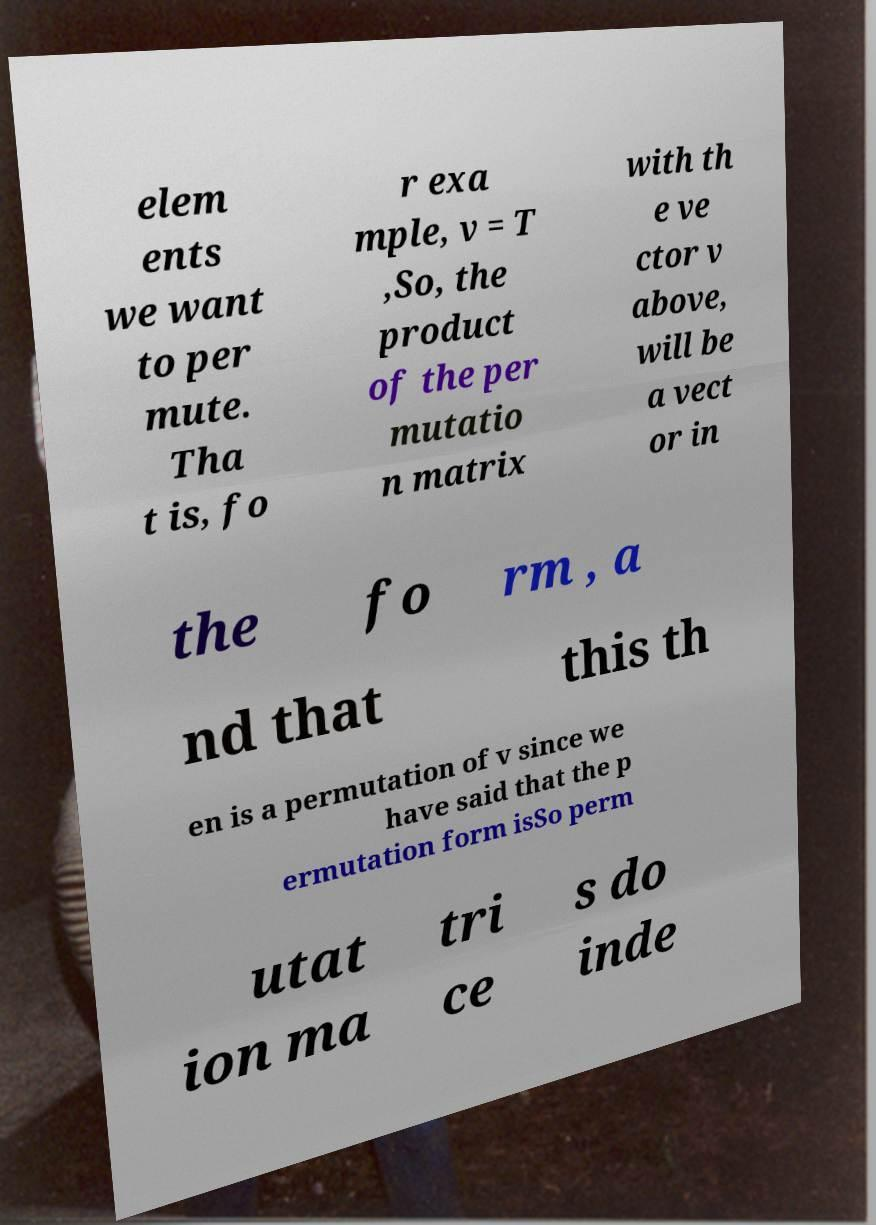Could you assist in decoding the text presented in this image and type it out clearly? elem ents we want to per mute. Tha t is, fo r exa mple, v = T ,So, the product of the per mutatio n matrix with th e ve ctor v above, will be a vect or in the fo rm , a nd that this th en is a permutation of v since we have said that the p ermutation form isSo perm utat ion ma tri ce s do inde 